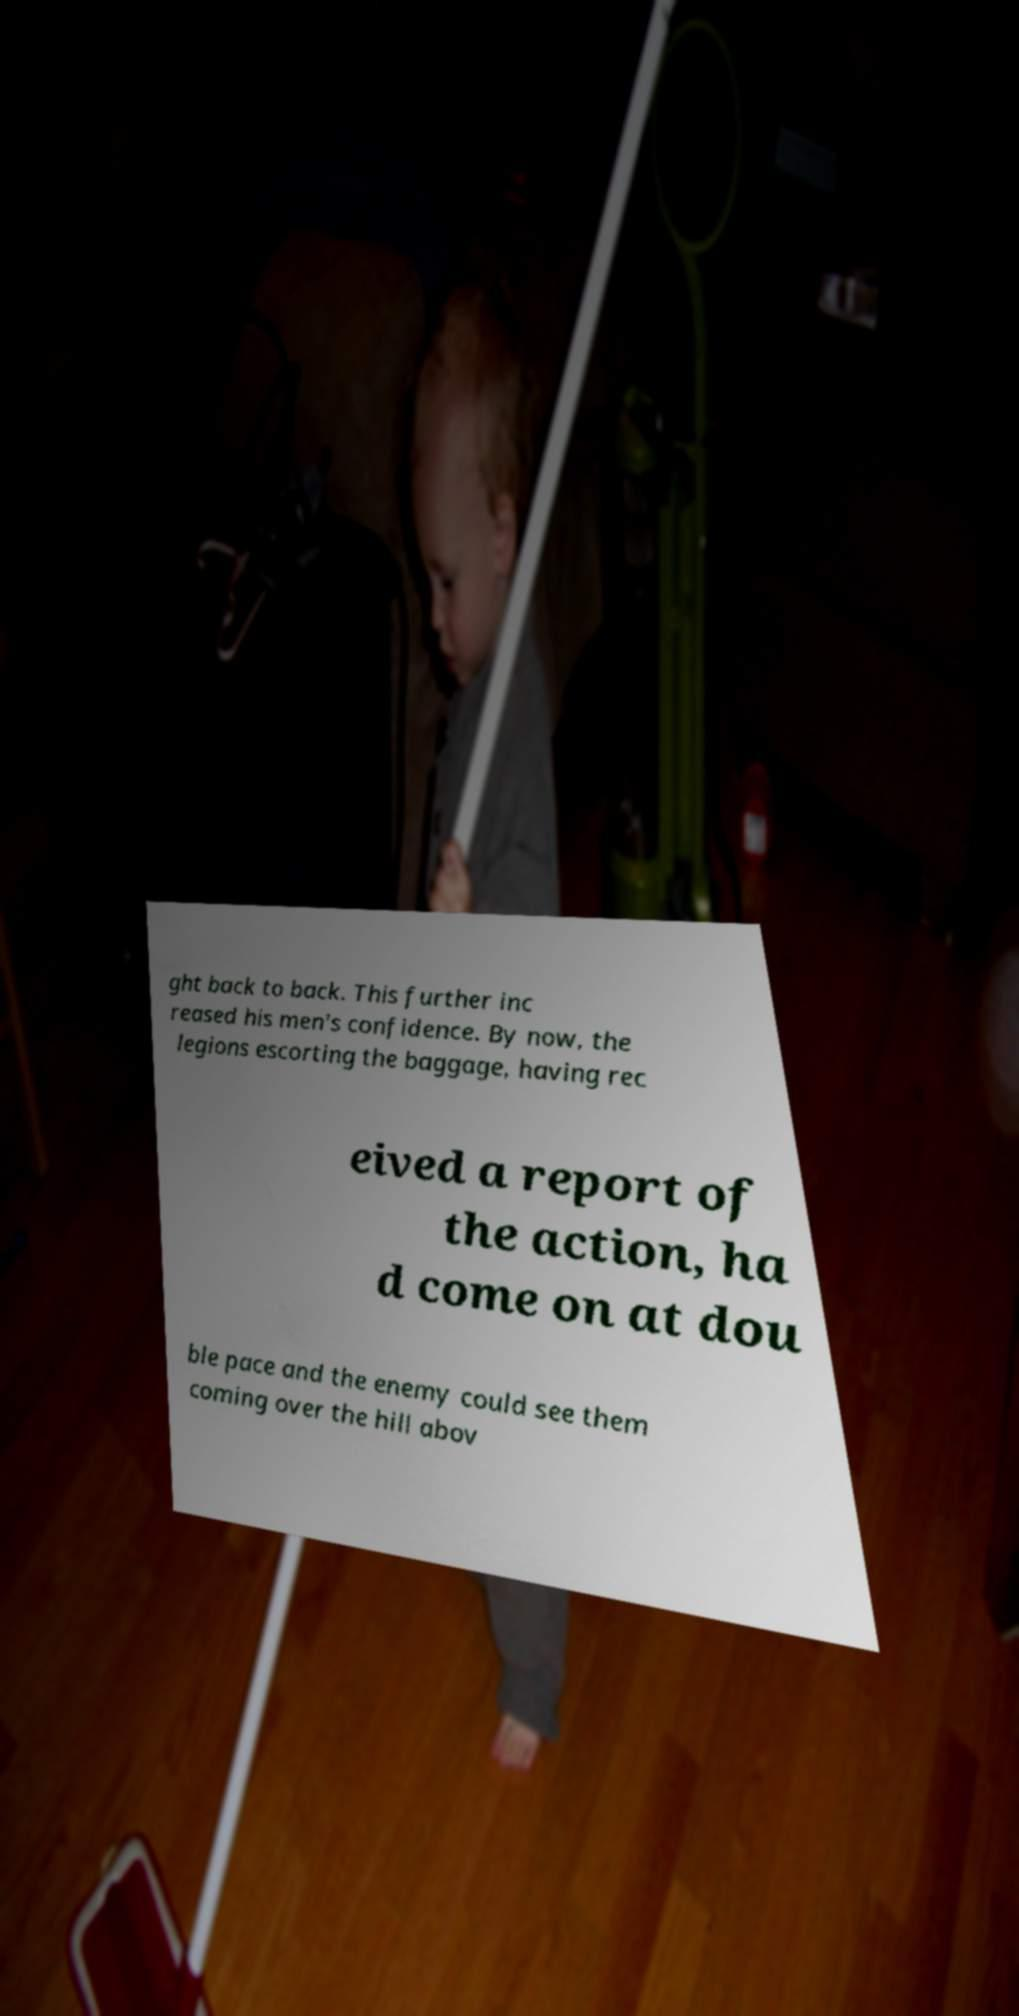Could you assist in decoding the text presented in this image and type it out clearly? ght back to back. This further inc reased his men's confidence. By now, the legions escorting the baggage, having rec eived a report of the action, ha d come on at dou ble pace and the enemy could see them coming over the hill abov 